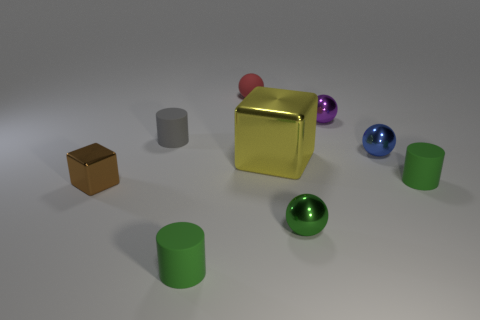How many objects are resting directly on the floor? Excluding the shadowed patches, there appear to be seven objects resting directly on the floor in the scene. Can you specify the shapes of the objects on the floor? Certainly, starting from the left, there's a small brown cube, two cylinders of different sizes, a large golden cube, another cylinder, and finally, two spheres. 